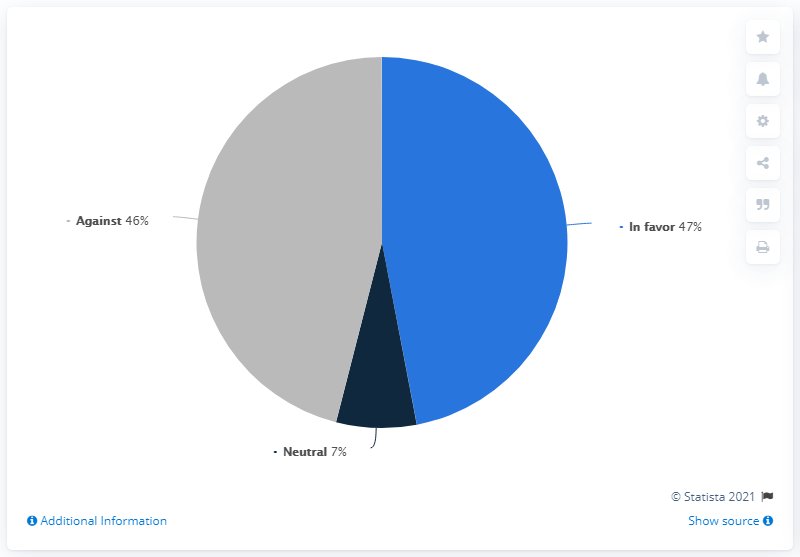Give some essential details in this illustration. According to the survey, 47% of respondents expressed support for a BeNeLiga in 2020. Out of the total number of people, 46% are against something. The sum of blues is 54. 